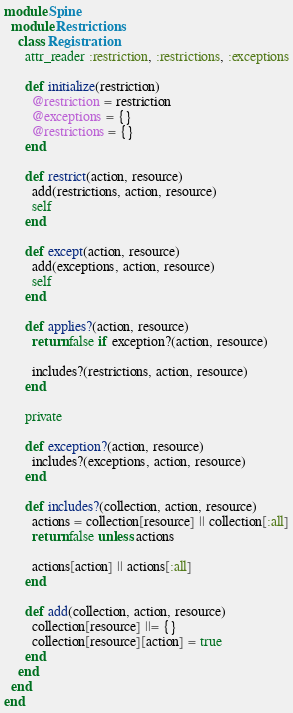Convert code to text. <code><loc_0><loc_0><loc_500><loc_500><_Ruby_>module Spine
  module Restrictions
    class Registration
      attr_reader :restriction, :restrictions, :exceptions

      def initialize(restriction)
        @restriction = restriction
        @exceptions = {}
        @restrictions = {}
      end

      def restrict(action, resource)
        add(restrictions, action, resource)
        self
      end

      def except(action, resource)
        add(exceptions, action, resource)
        self
      end

      def applies?(action, resource)
        return false if exception?(action, resource)

        includes?(restrictions, action, resource)
      end

      private

      def exception?(action, resource)
        includes?(exceptions, action, resource)
      end

      def includes?(collection, action, resource)
        actions = collection[resource] || collection[:all]
        return false unless actions

        actions[action] || actions[:all]
      end

      def add(collection, action, resource)
        collection[resource] ||= {}
        collection[resource][action] = true
      end
    end
  end
end
</code> 